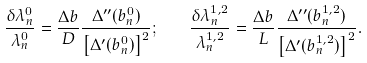Convert formula to latex. <formula><loc_0><loc_0><loc_500><loc_500>\frac { \delta \lambda _ { n } ^ { 0 } } { \lambda _ { n } ^ { 0 } } = \frac { \Delta b } { D } \frac { \Delta ^ { \prime \prime } ( b _ { n } ^ { 0 } ) } { \left [ \Delta ^ { \prime } ( b _ { n } ^ { 0 } ) \right ] ^ { 2 } } ; \quad \frac { \delta \lambda _ { n } ^ { 1 , 2 } } { \lambda _ { n } ^ { 1 , 2 } } = \frac { \Delta b } { L } \frac { \Delta ^ { \prime \prime } ( b _ { n } ^ { 1 , 2 } ) } { \left [ \Delta ^ { \prime } ( b _ { n } ^ { 1 , 2 } ) \right ] ^ { 2 } } .</formula> 